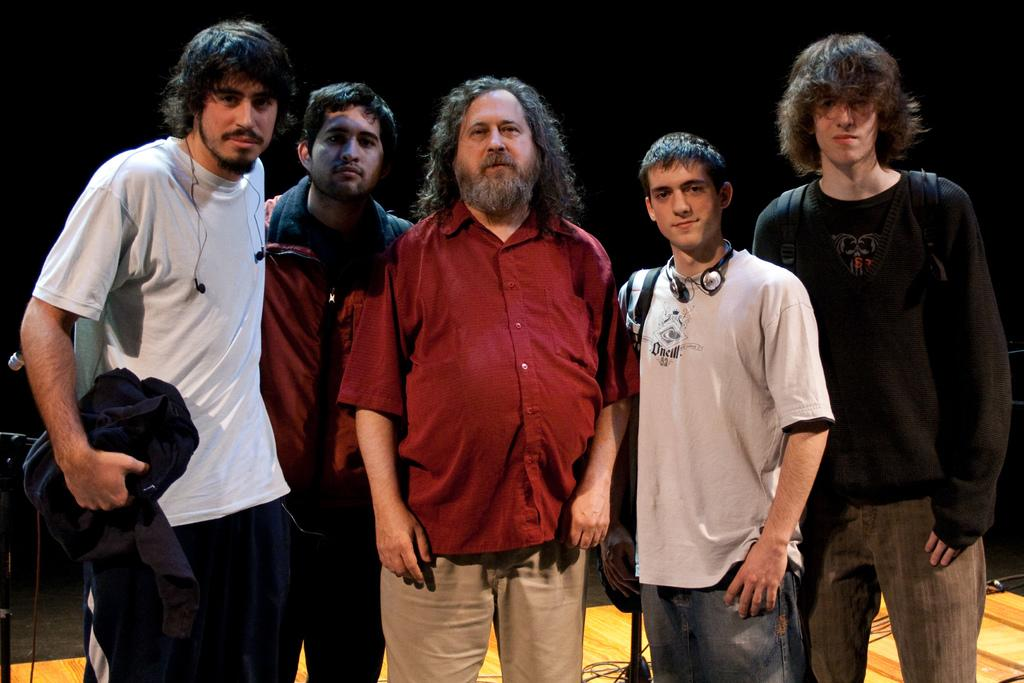How many people are present in the image? There are five persons in the image. What can be observed about the attire of the persons? The persons are wearing different color dresses. What is the posture of the persons in the image? All the persons are standing. What is one person holding in the image? One person is holding a cloth. What is the color of the background in the image? The background of the image is dark in color. What type of baby is visible in the image? There is no baby present in the image. What topic are the persons discussing in the image? The image does not depict a discussion among the persons. 